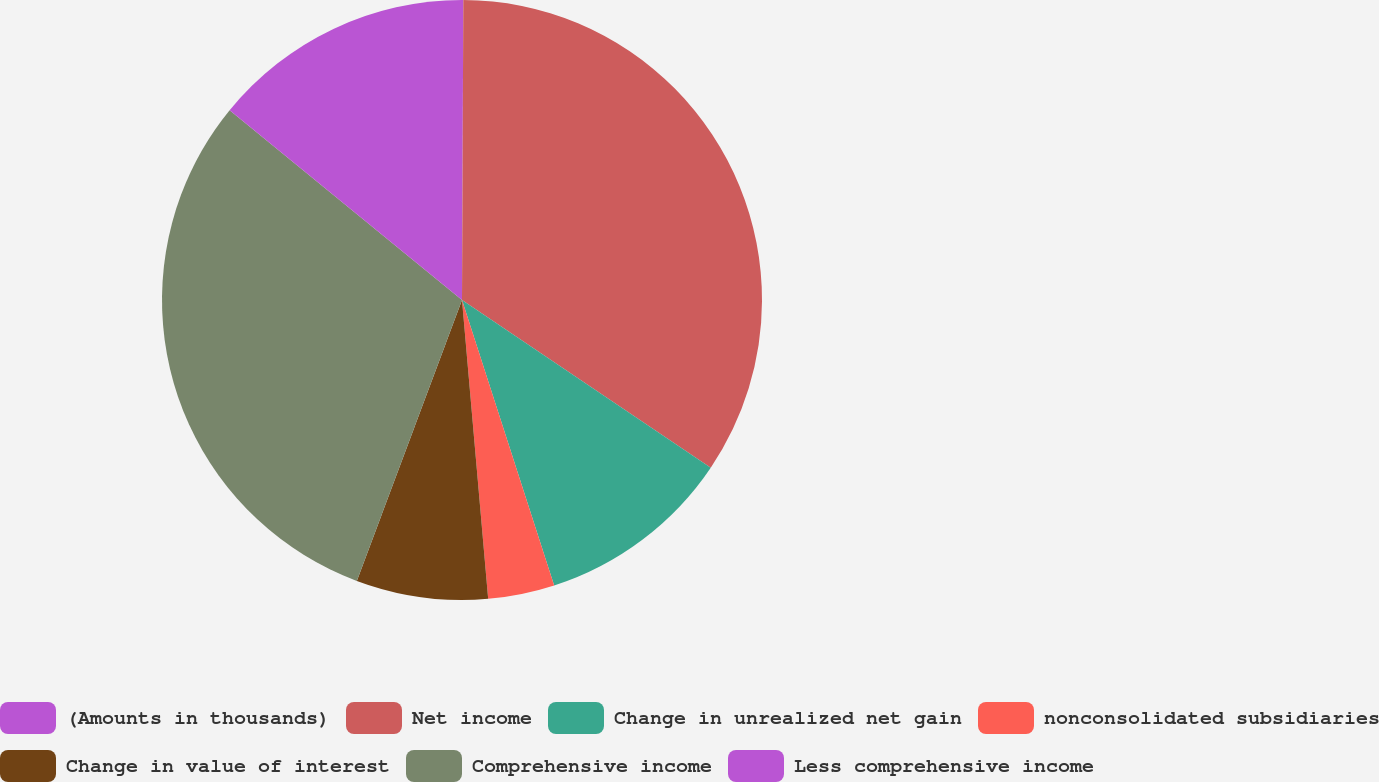Convert chart. <chart><loc_0><loc_0><loc_500><loc_500><pie_chart><fcel>(Amounts in thousands)<fcel>Net income<fcel>Change in unrealized net gain<fcel>nonconsolidated subsidiaries<fcel>Change in value of interest<fcel>Comprehensive income<fcel>Less comprehensive income<nl><fcel>0.07%<fcel>34.37%<fcel>10.59%<fcel>3.58%<fcel>7.09%<fcel>30.2%<fcel>14.1%<nl></chart> 